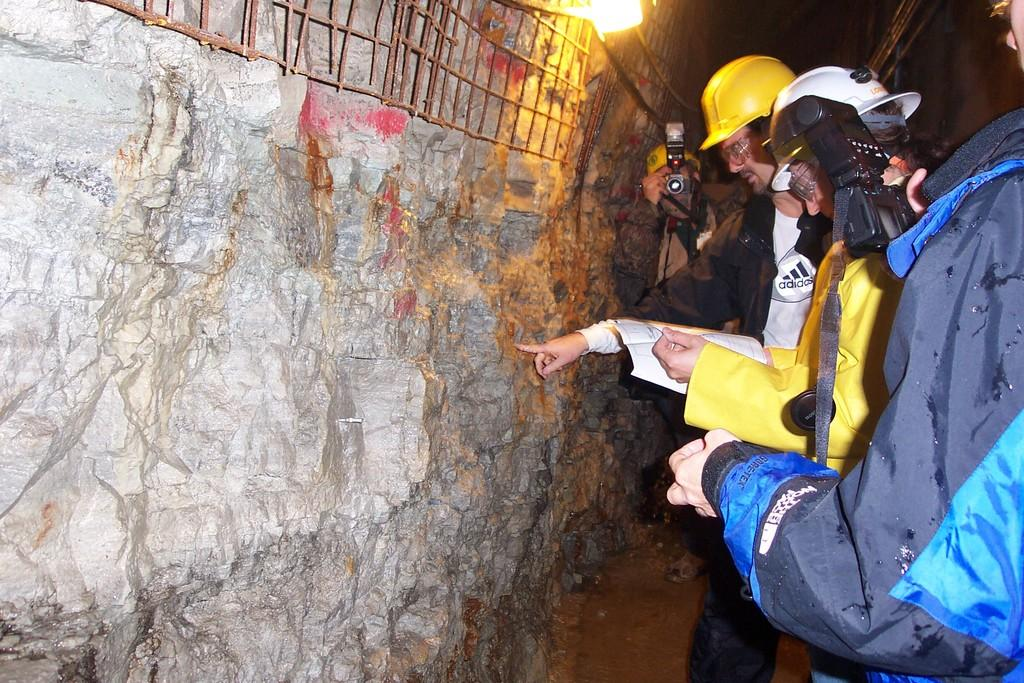What can be seen on the right side of the image? There are people on the right side of the image. What are some of the people wearing? Some people are wearing helmets. What are some of the people holding? Some people are holding cameras. What objects are in front of the people? Metal rods, a light, and a rock are in front of the people. What type of bean is being cut by the scissors in the image? There are no beans or scissors present in the image. What form does the rock take in the image? The rock is a natural, irregularly shaped object and does not take a specific form in the image. 